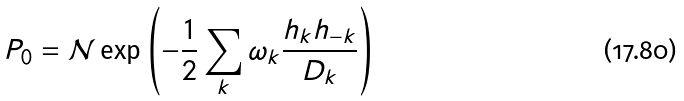Convert formula to latex. <formula><loc_0><loc_0><loc_500><loc_500>P _ { 0 } = \mathcal { N } \exp \left ( - \frac { 1 } { 2 } \sum _ { k } \omega _ { k } \frac { h _ { k } h _ { - { k } } } { D _ { k } } \right )</formula> 